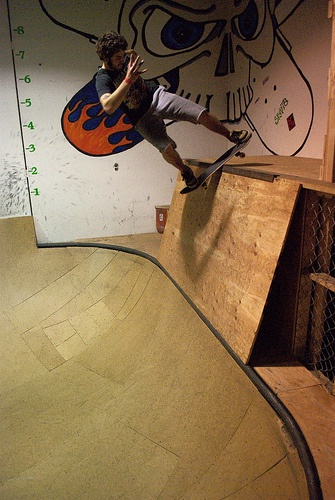Describe the objects in this image and their specific colors. I can see people in black, maroon, and gray tones and skateboard in black, maroon, and gray tones in this image. 